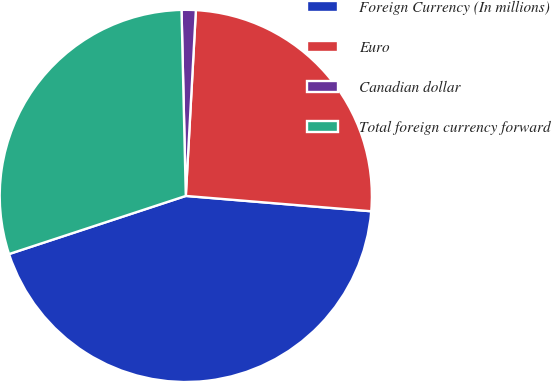Convert chart to OTSL. <chart><loc_0><loc_0><loc_500><loc_500><pie_chart><fcel>Foreign Currency (In millions)<fcel>Euro<fcel>Canadian dollar<fcel>Total foreign currency forward<nl><fcel>43.63%<fcel>25.45%<fcel>1.23%<fcel>29.69%<nl></chart> 